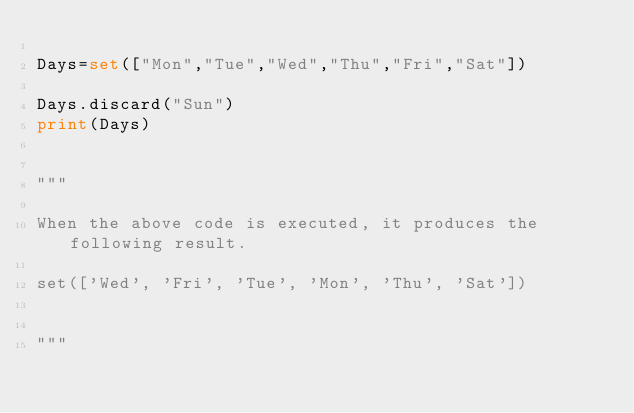Convert code to text. <code><loc_0><loc_0><loc_500><loc_500><_Python_>
Days=set(["Mon","Tue","Wed","Thu","Fri","Sat"])
 
Days.discard("Sun")
print(Days)


"""

When the above code is executed, it produces the following result.

set(['Wed', 'Fri', 'Tue', 'Mon', 'Thu', 'Sat'])


"""






</code> 